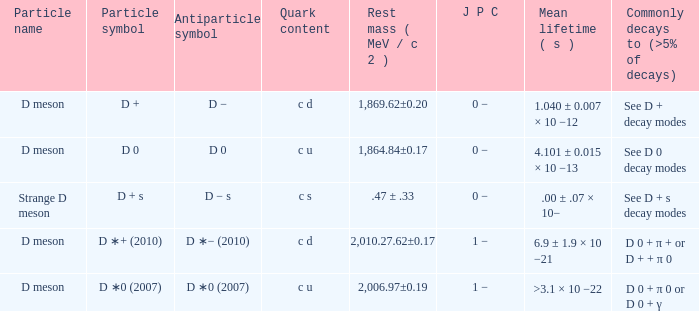Identify the jpc that typically decays (>5% of decays) to d0 + π0 or d0 + γ. 1 −. 